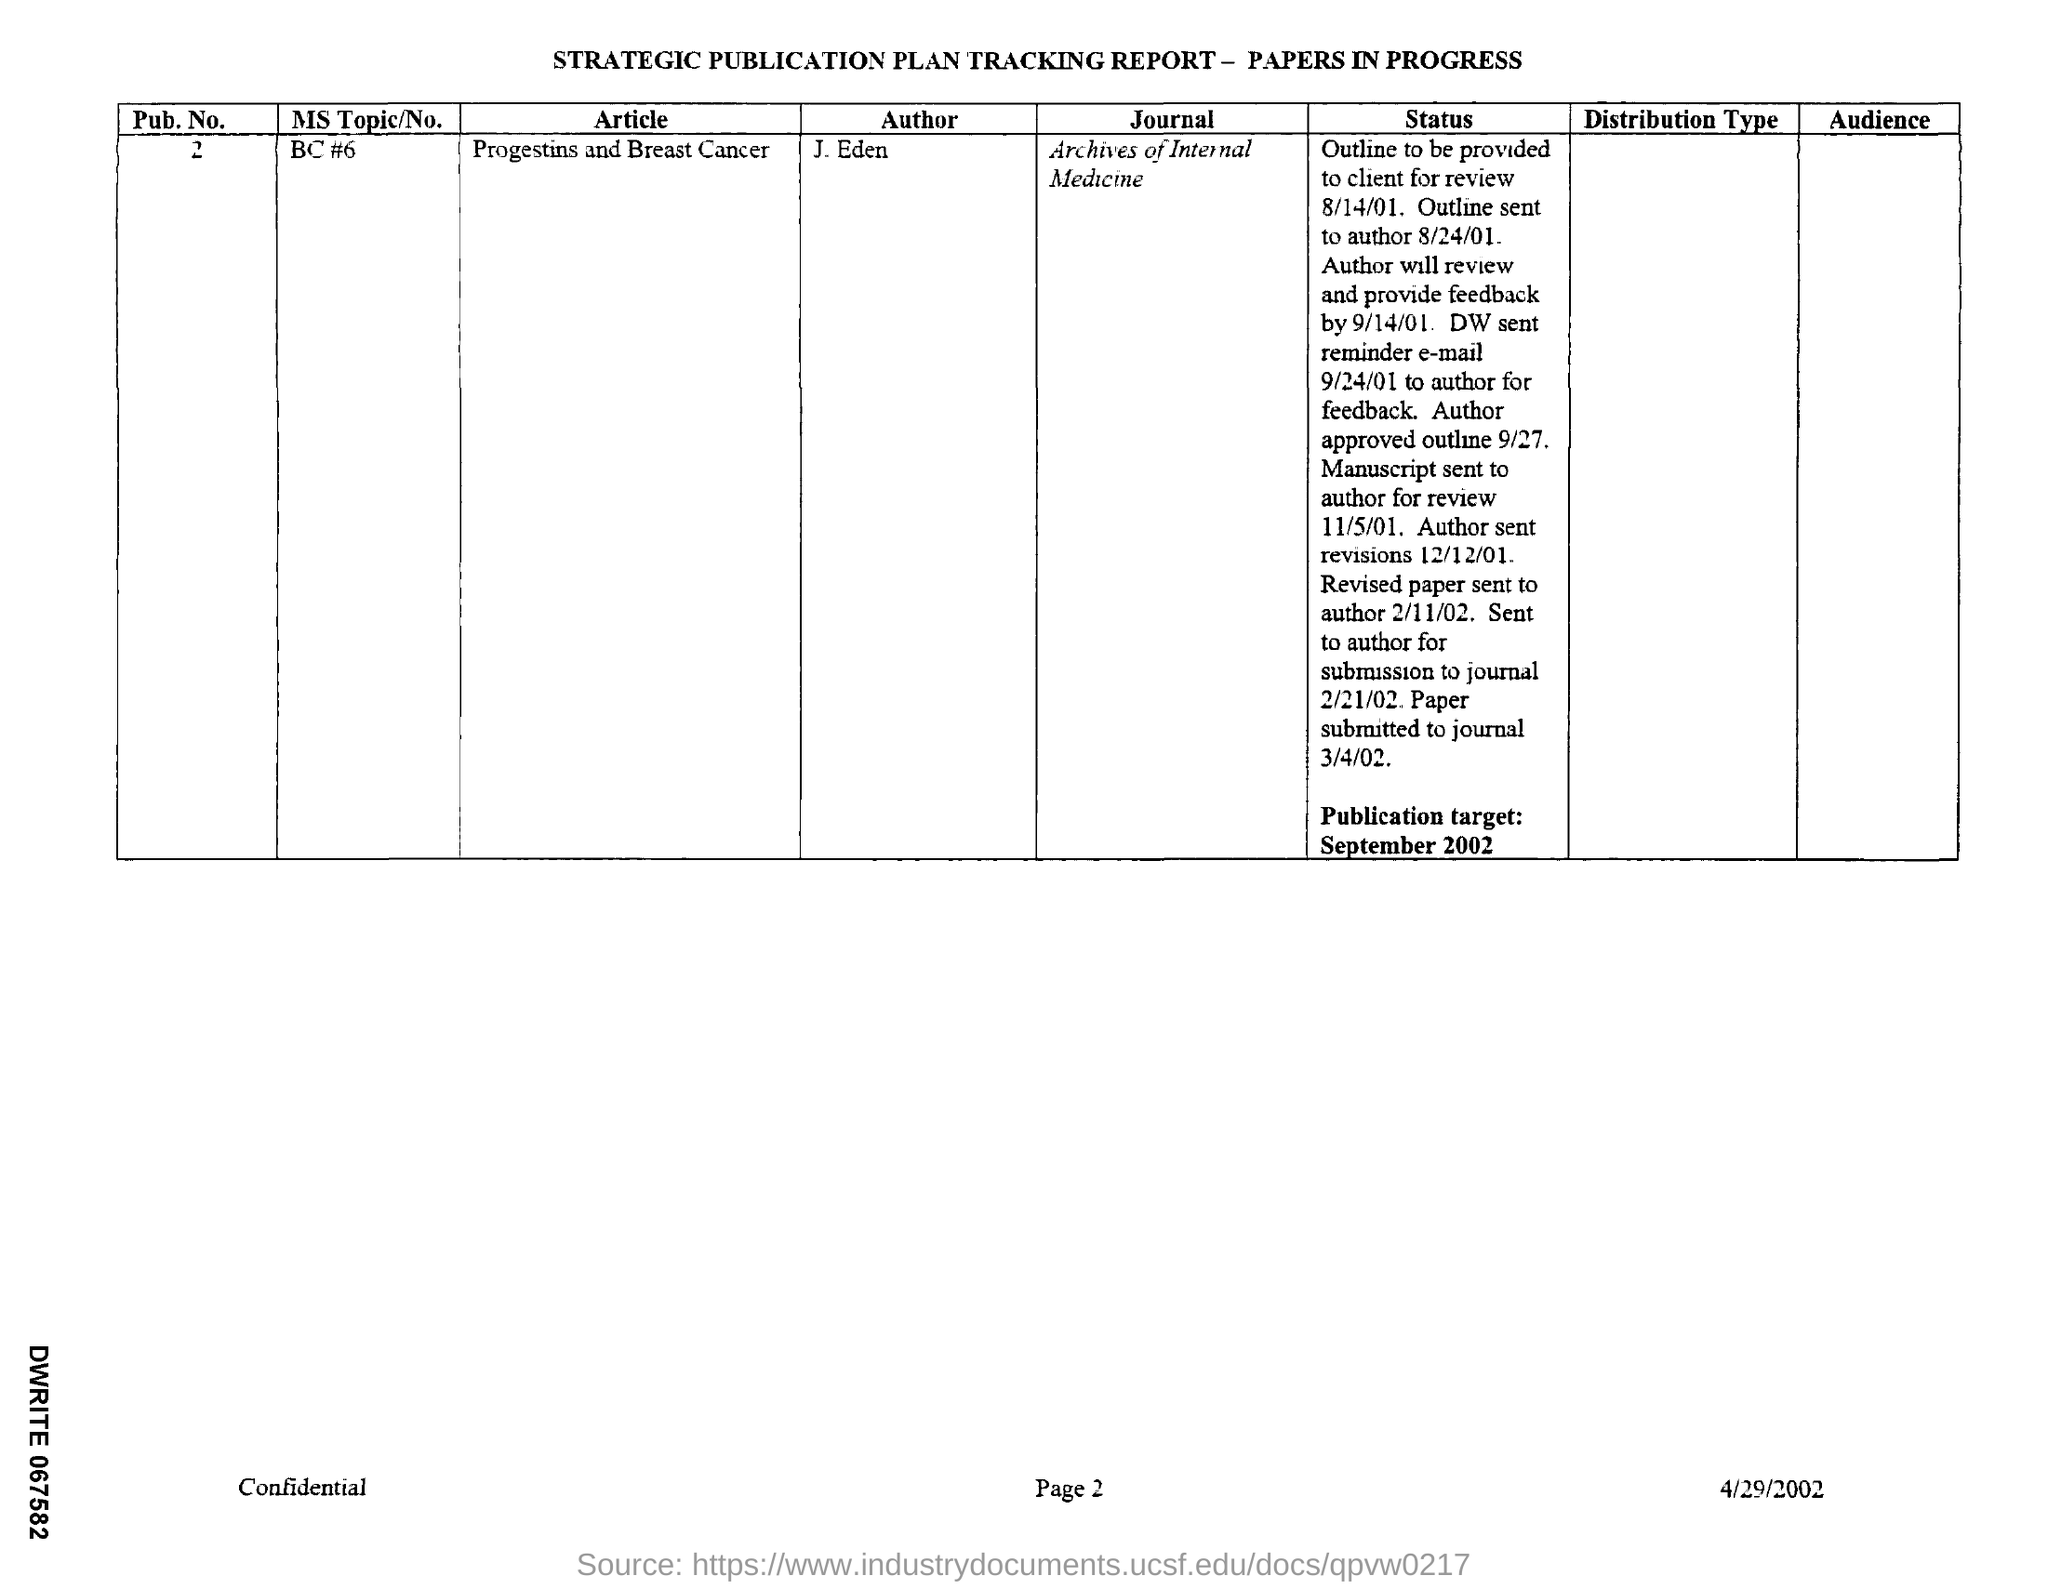Can you tell me more about the author's history with this publication? The author, J. Eden, has a history outlined in the tracking report. His work on 'Progestins and Breast Cancer' went through multiple stages of review and feedback. It was first sent to the author for review in August 2001, with several revisions before final submission to the 'Archives of Internal Medicine' in March 2002. What can you infer about the publishing process from the details in the image? From the details available, the publishing process appears rigorous and involves multiple rounds of reviews. The intended publication date was targeted for September 2002, indicating a long lead time which is typical for thorough peer-reviewed journals to ensure quality and accuracy of the research presented. 